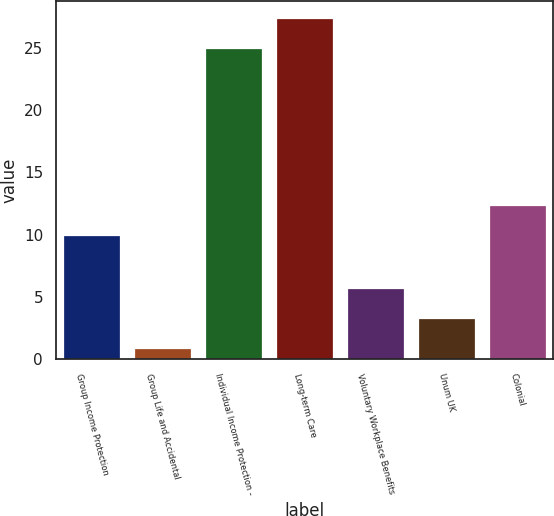<chart> <loc_0><loc_0><loc_500><loc_500><bar_chart><fcel>Group Income Protection<fcel>Group Life and Accidental<fcel>Individual Income Protection -<fcel>Long-term Care<fcel>Voluntary Workplace Benefits<fcel>Unum UK<fcel>Colonial<nl><fcel>10<fcel>0.88<fcel>25<fcel>27.41<fcel>5.7<fcel>3.29<fcel>12.41<nl></chart> 